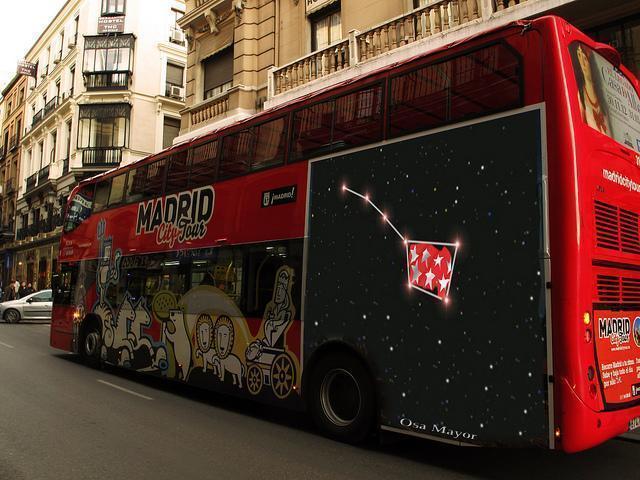What is this constellation often called in English?
Select the accurate response from the four choices given to answer the question.
Options: Orion, big dipper, pisces, virgo. Big dipper. 